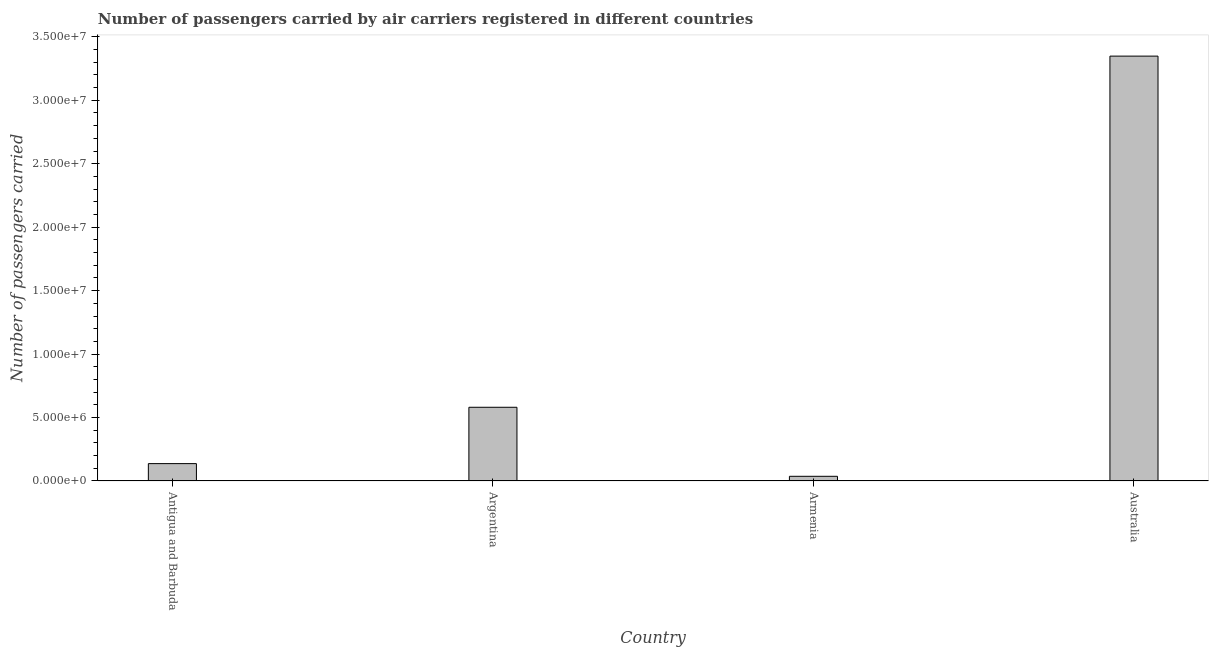Does the graph contain any zero values?
Offer a terse response. No. What is the title of the graph?
Ensure brevity in your answer.  Number of passengers carried by air carriers registered in different countries. What is the label or title of the X-axis?
Your answer should be compact. Country. What is the label or title of the Y-axis?
Offer a very short reply. Number of passengers carried. What is the number of passengers carried in Australia?
Your answer should be compact. 3.35e+07. Across all countries, what is the maximum number of passengers carried?
Your answer should be very brief. 3.35e+07. Across all countries, what is the minimum number of passengers carried?
Provide a short and direct response. 3.69e+05. In which country was the number of passengers carried maximum?
Offer a very short reply. Australia. In which country was the number of passengers carried minimum?
Give a very brief answer. Armenia. What is the sum of the number of passengers carried?
Provide a succinct answer. 4.10e+07. What is the difference between the number of passengers carried in Argentina and Australia?
Provide a short and direct response. -2.77e+07. What is the average number of passengers carried per country?
Offer a very short reply. 1.03e+07. What is the median number of passengers carried?
Give a very brief answer. 3.59e+06. In how many countries, is the number of passengers carried greater than 10000000 ?
Ensure brevity in your answer.  1. What is the ratio of the number of passengers carried in Antigua and Barbuda to that in Argentina?
Give a very brief answer. 0.24. Is the number of passengers carried in Armenia less than that in Australia?
Offer a very short reply. Yes. Is the difference between the number of passengers carried in Argentina and Armenia greater than the difference between any two countries?
Offer a terse response. No. What is the difference between the highest and the second highest number of passengers carried?
Provide a short and direct response. 2.77e+07. What is the difference between the highest and the lowest number of passengers carried?
Make the answer very short. 3.31e+07. In how many countries, is the number of passengers carried greater than the average number of passengers carried taken over all countries?
Make the answer very short. 1. What is the difference between two consecutive major ticks on the Y-axis?
Offer a terse response. 5.00e+06. Are the values on the major ticks of Y-axis written in scientific E-notation?
Offer a very short reply. Yes. What is the Number of passengers carried of Antigua and Barbuda?
Your response must be concise. 1.37e+06. What is the Number of passengers carried of Argentina?
Provide a succinct answer. 5.81e+06. What is the Number of passengers carried in Armenia?
Offer a very short reply. 3.69e+05. What is the Number of passengers carried of Australia?
Keep it short and to the point. 3.35e+07. What is the difference between the Number of passengers carried in Antigua and Barbuda and Argentina?
Give a very brief answer. -4.44e+06. What is the difference between the Number of passengers carried in Antigua and Barbuda and Armenia?
Your answer should be compact. 1.00e+06. What is the difference between the Number of passengers carried in Antigua and Barbuda and Australia?
Keep it short and to the point. -3.21e+07. What is the difference between the Number of passengers carried in Argentina and Armenia?
Your answer should be compact. 5.44e+06. What is the difference between the Number of passengers carried in Argentina and Australia?
Make the answer very short. -2.77e+07. What is the difference between the Number of passengers carried in Armenia and Australia?
Ensure brevity in your answer.  -3.31e+07. What is the ratio of the Number of passengers carried in Antigua and Barbuda to that in Argentina?
Your response must be concise. 0.24. What is the ratio of the Number of passengers carried in Antigua and Barbuda to that in Armenia?
Keep it short and to the point. 3.71. What is the ratio of the Number of passengers carried in Antigua and Barbuda to that in Australia?
Provide a succinct answer. 0.04. What is the ratio of the Number of passengers carried in Argentina to that in Armenia?
Give a very brief answer. 15.73. What is the ratio of the Number of passengers carried in Argentina to that in Australia?
Give a very brief answer. 0.17. What is the ratio of the Number of passengers carried in Armenia to that in Australia?
Make the answer very short. 0.01. 